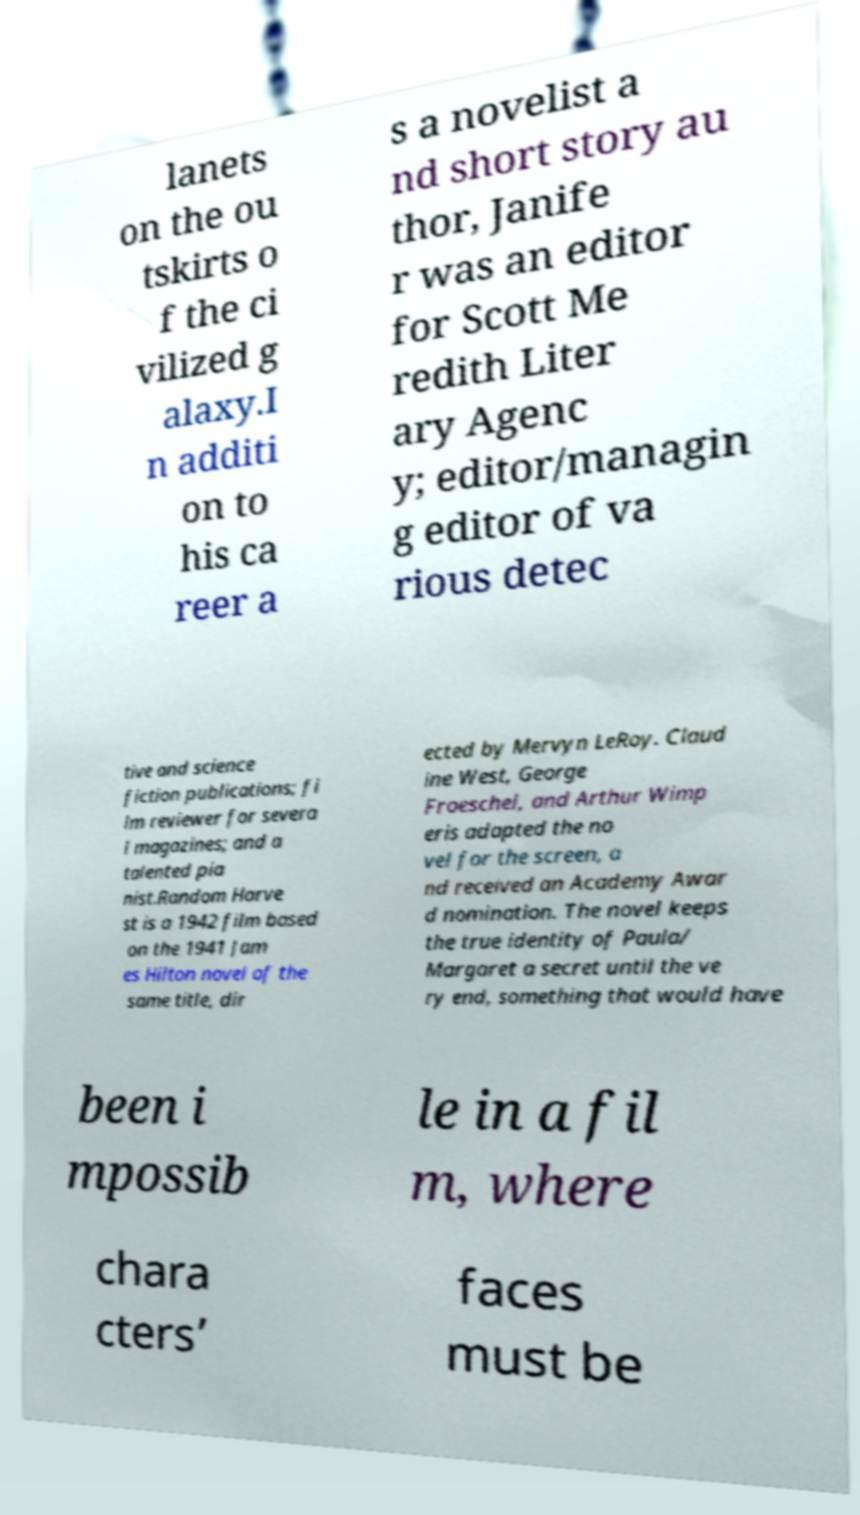Can you accurately transcribe the text from the provided image for me? lanets on the ou tskirts o f the ci vilized g alaxy.I n additi on to his ca reer a s a novelist a nd short story au thor, Janife r was an editor for Scott Me redith Liter ary Agenc y; editor/managin g editor of va rious detec tive and science fiction publications; fi lm reviewer for severa l magazines; and a talented pia nist.Random Harve st is a 1942 film based on the 1941 Jam es Hilton novel of the same title, dir ected by Mervyn LeRoy. Claud ine West, George Froeschel, and Arthur Wimp eris adapted the no vel for the screen, a nd received an Academy Awar d nomination. The novel keeps the true identity of Paula/ Margaret a secret until the ve ry end, something that would have been i mpossib le in a fil m, where chara cters’ faces must be 